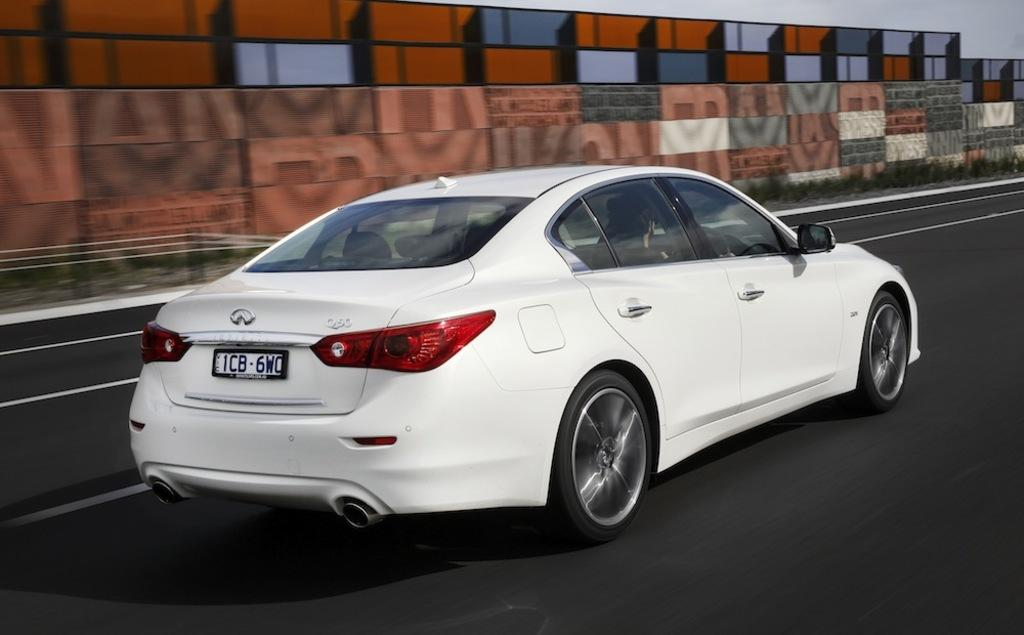What type of vehicle can be seen on the road in the image? There is a white color car visible on the road in the image. What is located at the top of the image? The wall and the sky visible at the top of the image? Who is the creator of the coast visible in the image? There is no coast visible in the image, so it is not possible to determine the creator. 